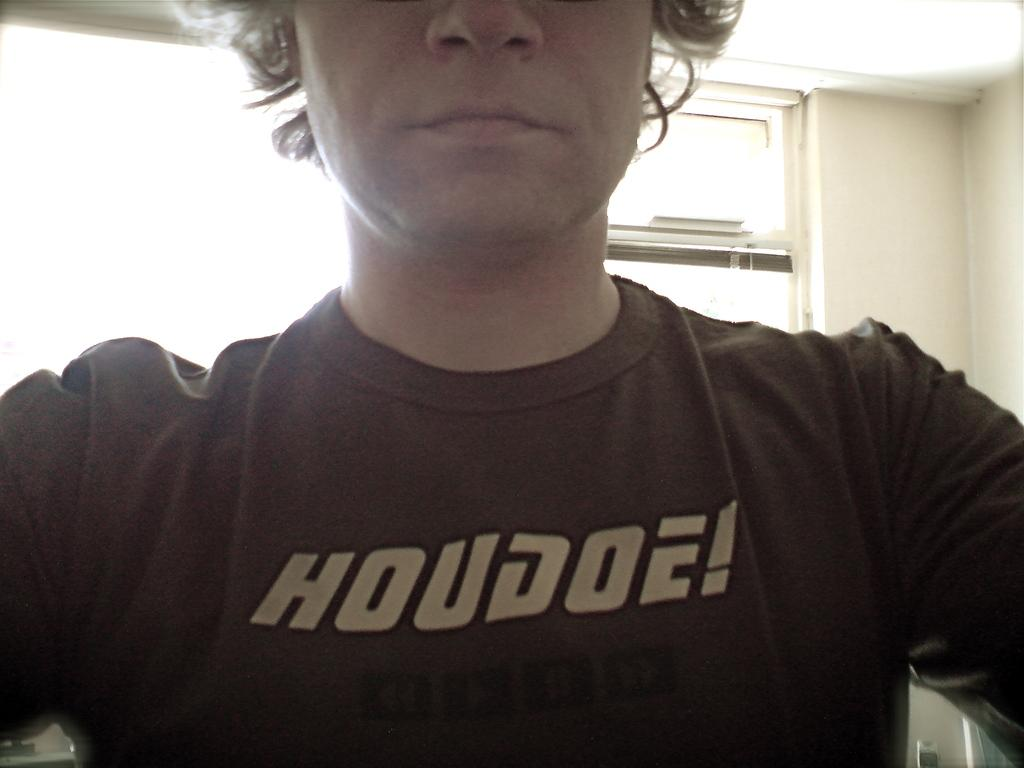Who or what is present in the image? There is a person in the image. What can be seen in the background of the image? There is a window and a wall in the background of the image. How many giants are visible in the image? There are no giants present in the image. What type of debt is being discussed in the image? There is no mention of debt in the image. 